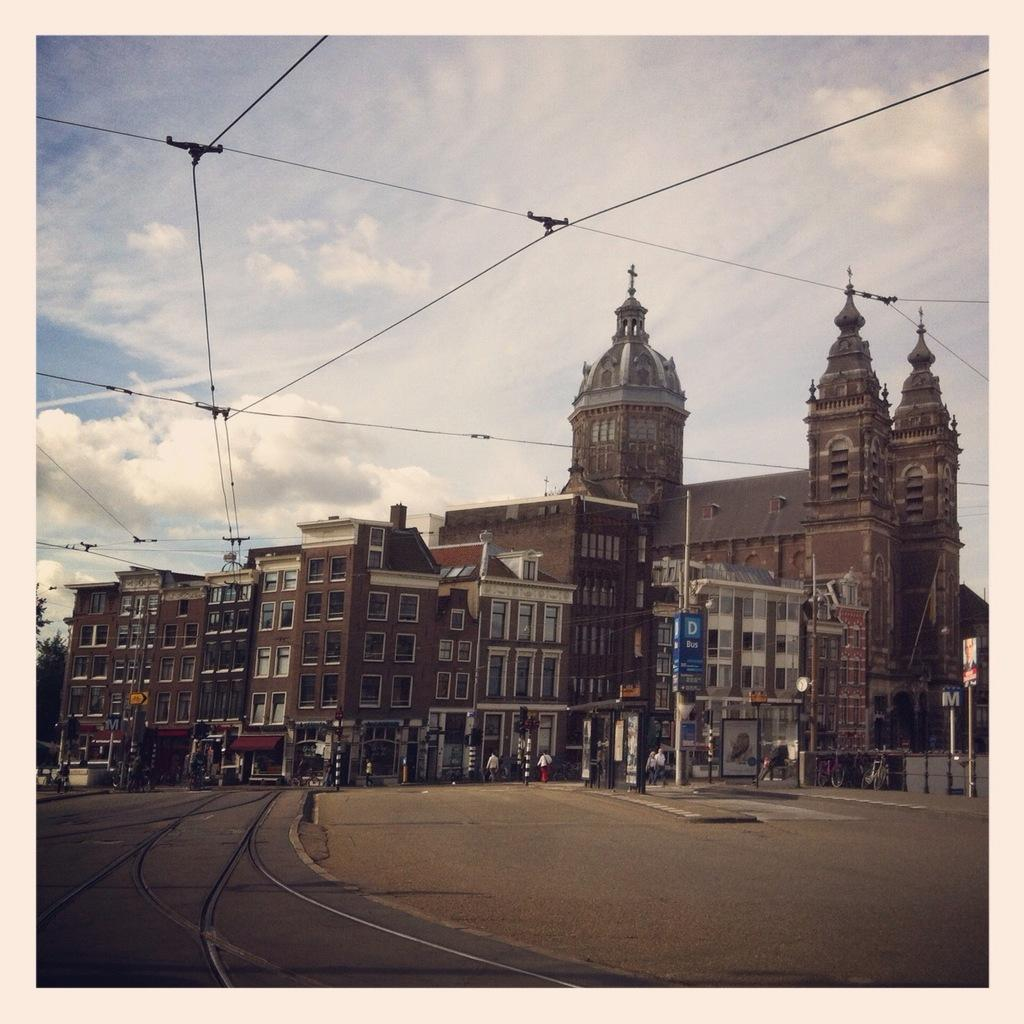What type of structures can be seen in the image? There are buildings in the image. Where is the railway track located in the image? The railway track is on the left side of the image. What else can be seen in the image besides buildings and the railway track? There are wires visible in the image. What is visible in the background of the image? There is a sky with clouds in the background of the image. What type of rhythm can be heard coming from the watch in the image? There is no watch present in the image, so it is not possible to determine the rhythm. 